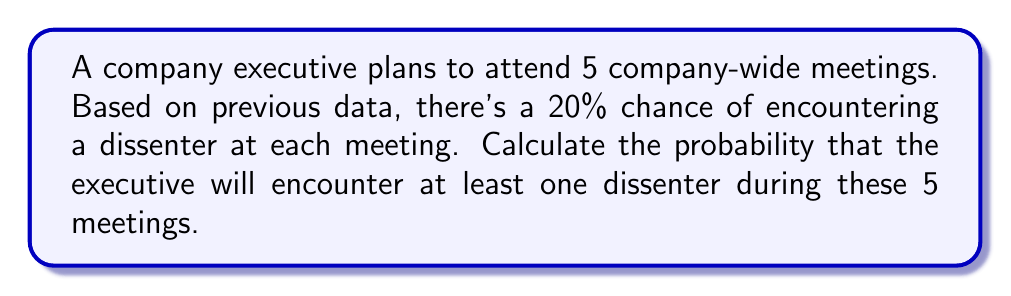Can you answer this question? Let's approach this step-by-step:

1) First, let's define our events:
   Let A be the event of encountering at least one dissenter in 5 meetings.
   
2) It's easier to calculate the probability of not encountering any dissenters and then subtract this from 1.
   
3) Probability of not encountering a dissenter in one meeting = 1 - 0.20 = 0.80

4) For all 5 meetings to have no dissenters, this must happen 5 times in a row. We can use the multiplication rule of probability:

   $P(\text{no dissenters in 5 meetings}) = 0.80^5$

5) Now we can calculate:
   
   $P(\text{no dissenters in 5 meetings}) = 0.80^5 = 0.32768$

6) Therefore, the probability of encountering at least one dissenter is:

   $P(A) = 1 - P(\text{no dissenters in 5 meetings})$
   $P(A) = 1 - 0.32768 = 0.67232$

7) Converting to a percentage:
   
   $0.67232 \times 100\% = 67.232\%$
Answer: 67.232% 